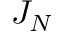<formula> <loc_0><loc_0><loc_500><loc_500>J _ { N }</formula> 